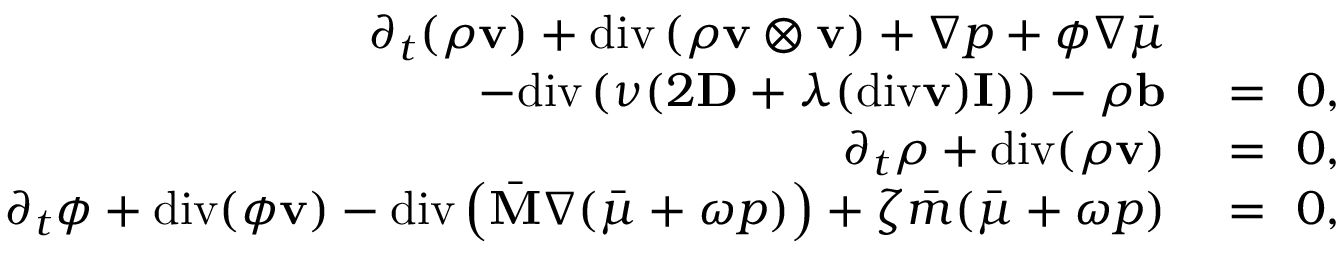<formula> <loc_0><loc_0><loc_500><loc_500>\begin{array} { r l } { \partial _ { t } ( \rho v ) + d i v \left ( \rho v \otimes v \right ) + \nabla p + \phi \nabla \bar { \mu } } \\ { - d i v \left ( \nu ( 2 D + \lambda ( d i v v ) I ) \right ) - \rho b } & = 0 , } \\ { \partial _ { t } \rho + d i v ( \rho v ) } & = 0 , } \\ { \partial _ { t } \phi + d i v ( \phi v ) - d i v \left ( \bar { M } \nabla ( \bar { \mu } + \omega p ) \right ) + \zeta \bar { m } ( \bar { \mu } + \omega p ) } & = 0 , } \end{array}</formula> 